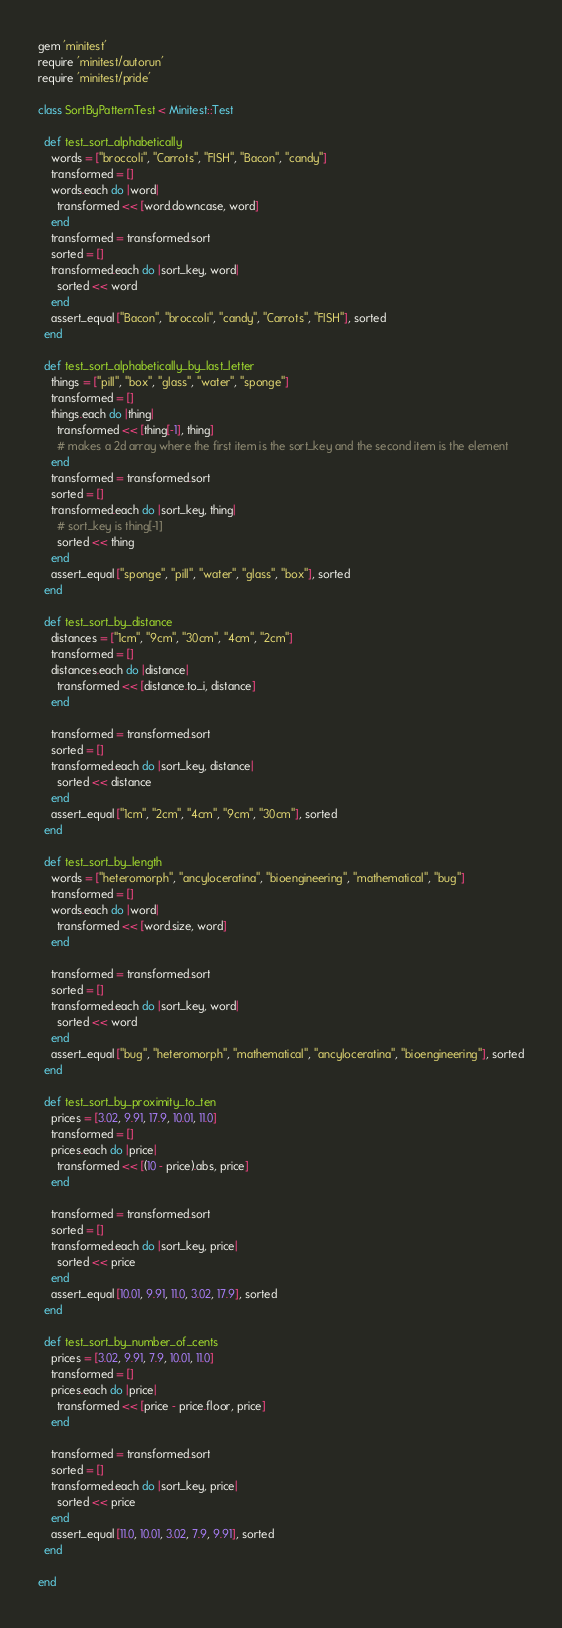<code> <loc_0><loc_0><loc_500><loc_500><_Ruby_>gem 'minitest'
require 'minitest/autorun'
require 'minitest/pride'

class SortByPatternTest < Minitest::Test

  def test_sort_alphabetically
    words = ["broccoli", "Carrots", "FISH", "Bacon", "candy"]
    transformed = []
    words.each do |word|
      transformed << [word.downcase, word]
    end
    transformed = transformed.sort
    sorted = []
    transformed.each do |sort_key, word|
      sorted << word
    end
    assert_equal ["Bacon", "broccoli", "candy", "Carrots", "FISH"], sorted
  end

  def test_sort_alphabetically_by_last_letter
    things = ["pill", "box", "glass", "water", "sponge"]
    transformed = []
    things.each do |thing|
      transformed << [thing[-1], thing]
      # makes a 2d array where the first item is the sort_key and the second item is the element
    end
    transformed = transformed.sort
    sorted = []
    transformed.each do |sort_key, thing|
      # sort_key is thing[-1]
      sorted << thing
    end
    assert_equal ["sponge", "pill", "water", "glass", "box"], sorted
  end

  def test_sort_by_distance
    distances = ["1cm", "9cm", "30cm", "4cm", "2cm"]
    transformed = []
    distances.each do |distance|
      transformed << [distance.to_i, distance]
    end

    transformed = transformed.sort
    sorted = []
    transformed.each do |sort_key, distance|
      sorted << distance
    end
    assert_equal ["1cm", "2cm", "4cm", "9cm", "30cm"], sorted
  end

  def test_sort_by_length
    words = ["heteromorph", "ancyloceratina", "bioengineering", "mathematical", "bug"]
    transformed = []
    words.each do |word|
      transformed << [word.size, word]
    end

    transformed = transformed.sort
    sorted = []
    transformed.each do |sort_key, word|
      sorted << word
    end
    assert_equal ["bug", "heteromorph", "mathematical", "ancyloceratina", "bioengineering"], sorted
  end

  def test_sort_by_proximity_to_ten
    prices = [3.02, 9.91, 17.9, 10.01, 11.0]
    transformed = []
    prices.each do |price|
      transformed << [(10 - price).abs, price]
    end

    transformed = transformed.sort
    sorted = []
    transformed.each do |sort_key, price|
      sorted << price
    end
    assert_equal [10.01, 9.91, 11.0, 3.02, 17.9], sorted
  end

  def test_sort_by_number_of_cents
    prices = [3.02, 9.91, 7.9, 10.01, 11.0]
    transformed = []
    prices.each do |price|
      transformed << [price - price.floor, price]
    end

    transformed = transformed.sort
    sorted = []
    transformed.each do |sort_key, price|
      sorted << price
    end
    assert_equal [11.0, 10.01, 3.02, 7.9, 9.91], sorted
  end

end
</code> 